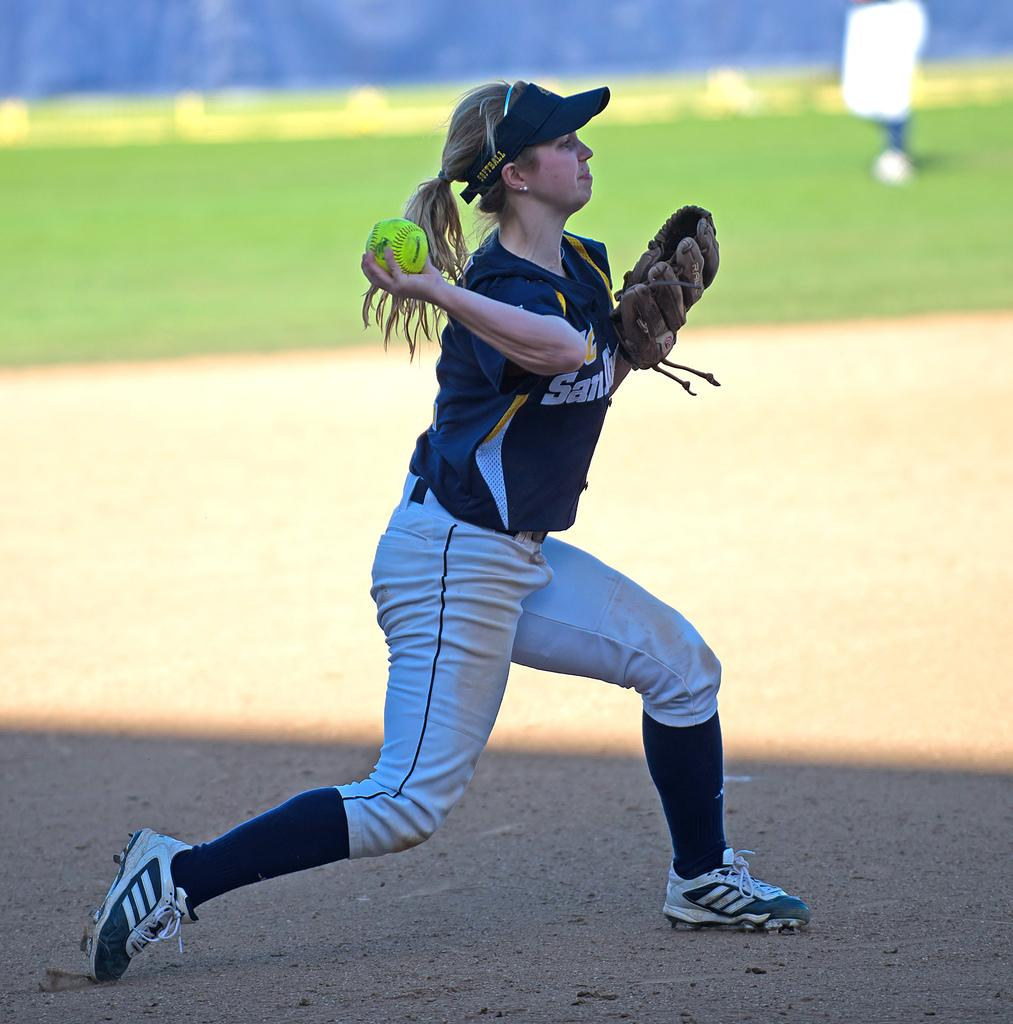<image>
Create a compact narrative representing the image presented. A player for San Diego gets ready to throw a pitch 